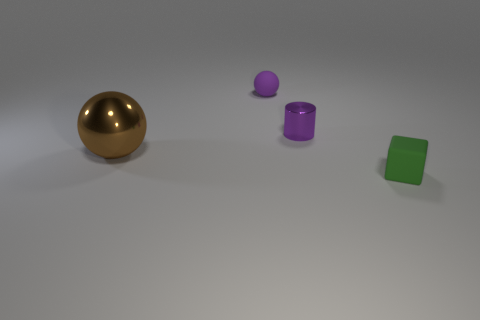Add 3 small metallic objects. How many objects exist? 7 Subtract all cubes. How many objects are left? 3 Add 1 large metal spheres. How many large metal spheres are left? 2 Add 4 green balls. How many green balls exist? 4 Subtract 1 purple cylinders. How many objects are left? 3 Subtract all metallic objects. Subtract all tiny green things. How many objects are left? 1 